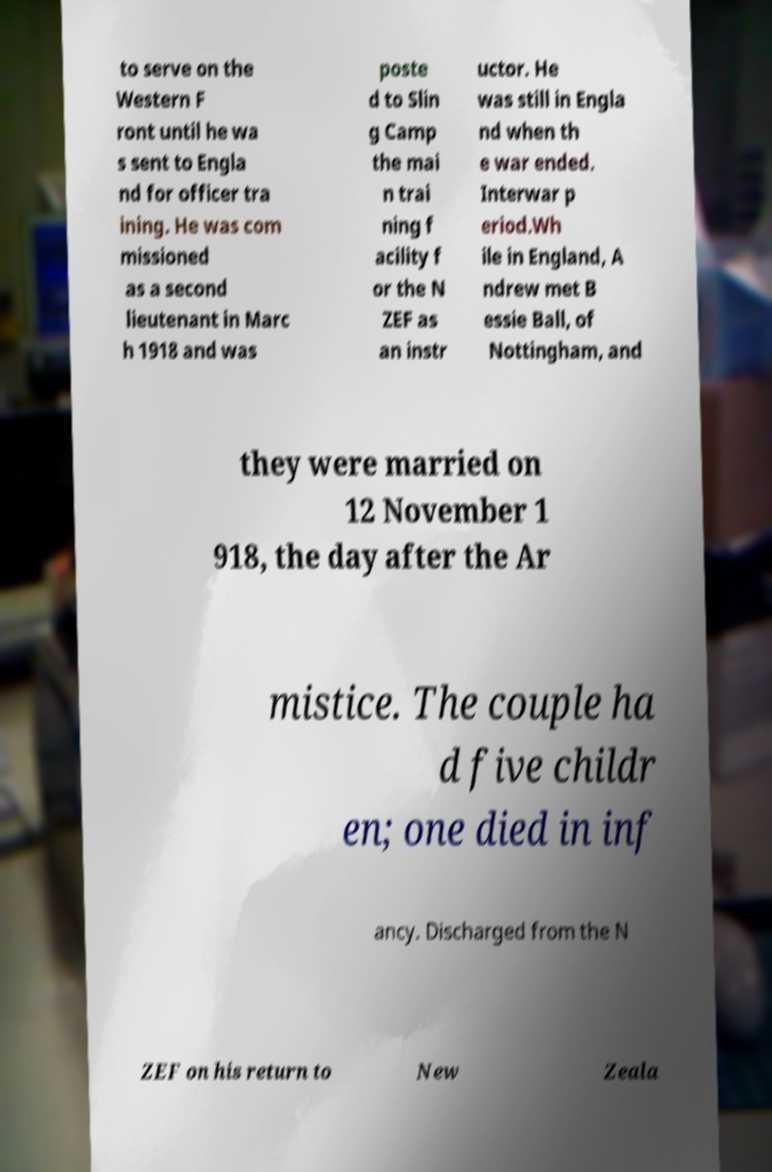I need the written content from this picture converted into text. Can you do that? to serve on the Western F ront until he wa s sent to Engla nd for officer tra ining. He was com missioned as a second lieutenant in Marc h 1918 and was poste d to Slin g Camp the mai n trai ning f acility f or the N ZEF as an instr uctor. He was still in Engla nd when th e war ended. Interwar p eriod.Wh ile in England, A ndrew met B essie Ball, of Nottingham, and they were married on 12 November 1 918, the day after the Ar mistice. The couple ha d five childr en; one died in inf ancy. Discharged from the N ZEF on his return to New Zeala 